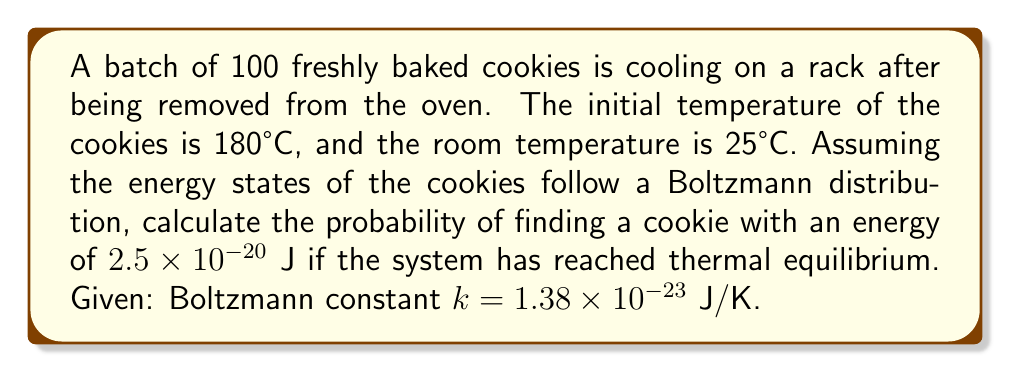Show me your answer to this math problem. To solve this problem, we'll use the Boltzmann distribution formula:

$$P(E) = \frac{1}{Z} e^{-E/kT}$$

Where:
- $P(E)$ is the probability of a system being in a state with energy $E$
- $Z$ is the partition function (normalization factor)
- $k$ is the Boltzmann constant
- $T$ is the temperature in Kelvin

Step 1: Convert room temperature to Kelvin
$T = 25°C + 273.15 = 298.15 K$

Step 2: Calculate $E/kT$
$$\frac{E}{kT} = \frac{2.5 \times 10^{-20}}{(1.38 \times 10^{-23})(298.15)} = 6.06$$

Step 3: Calculate $e^{-E/kT}$
$$e^{-E/kT} = e^{-6.06} = 0.00233$$

Step 4: The partition function $Z$ is unknown, but we can express the probability as:

$$P(E) = \frac{1}{Z} (0.00233)$$

The exact probability cannot be determined without knowing $Z$, but we can express it in terms of $1/Z$.
Answer: $P(E) = \frac{0.00233}{Z}$ 